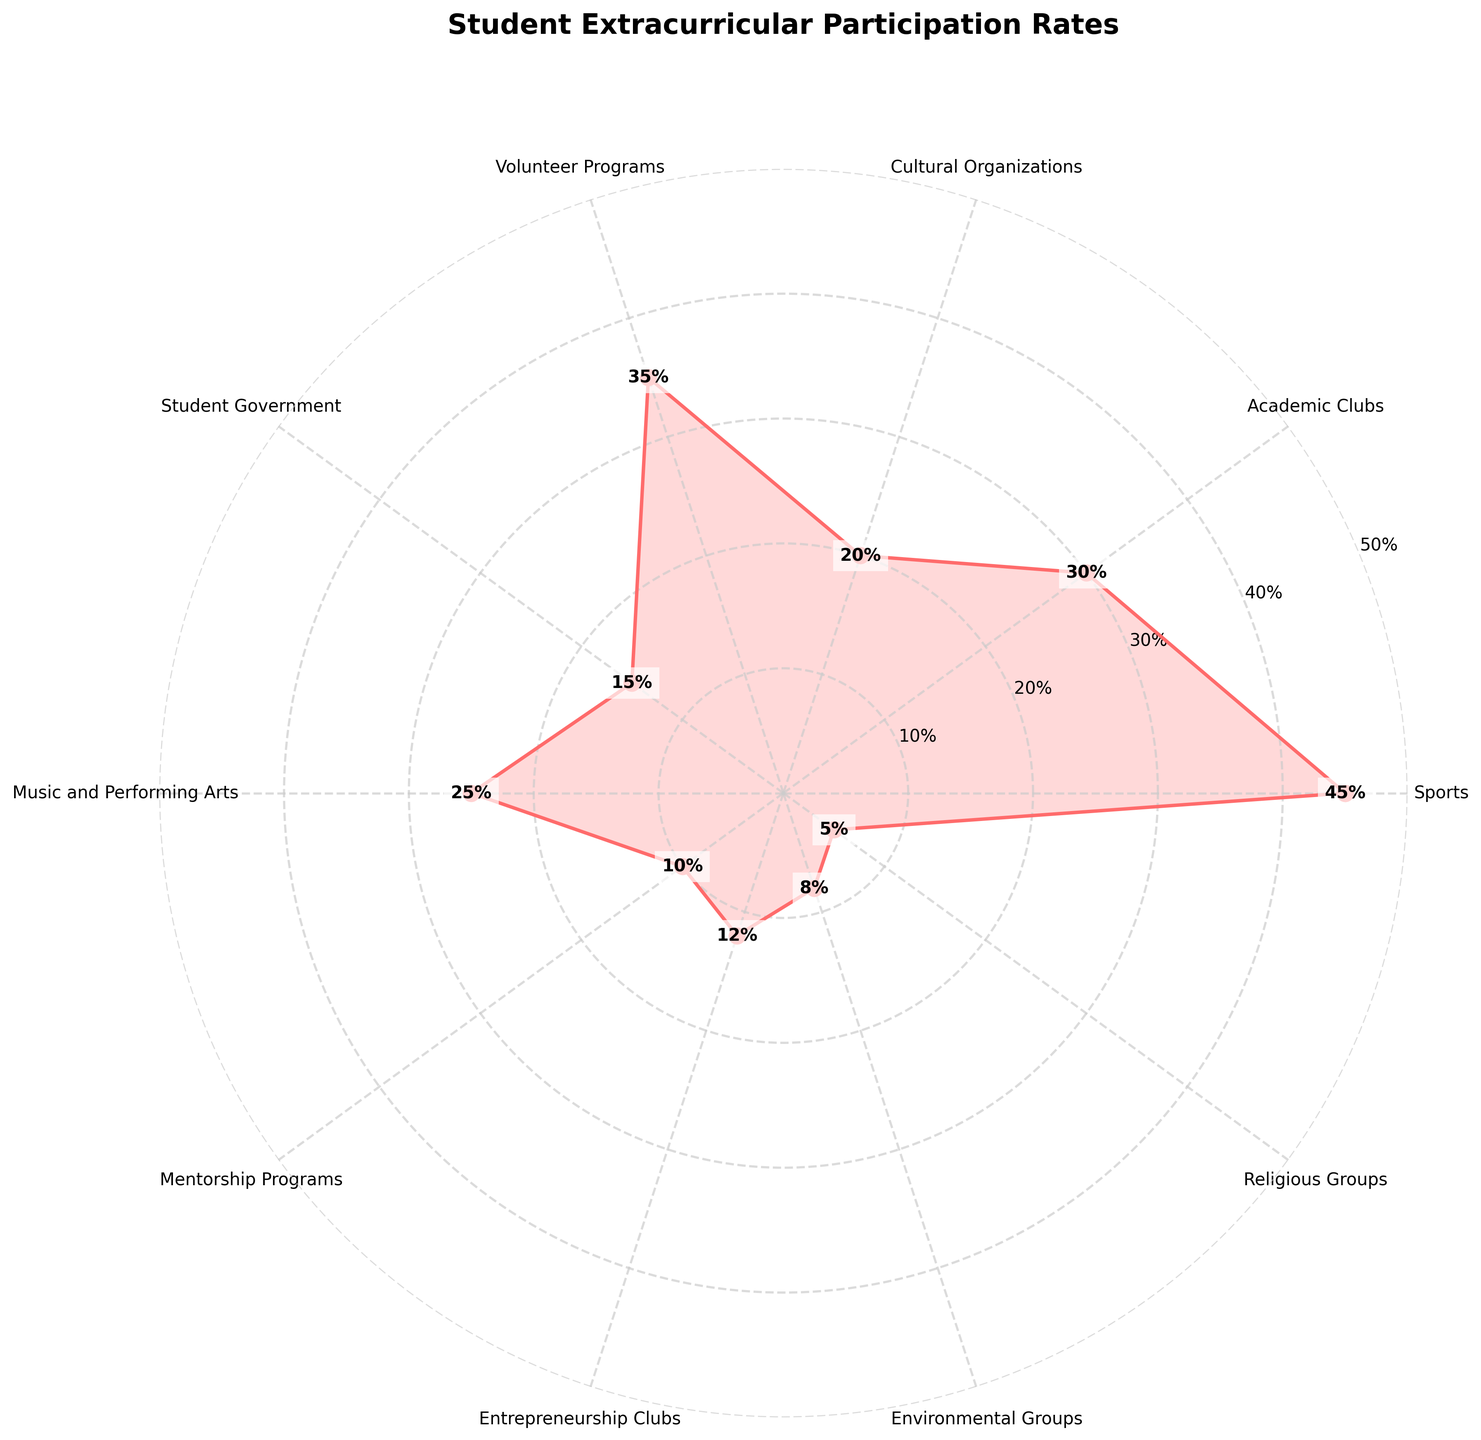What is the title of the figure? The title of the figure is usually located at the top and describes the main subject of the plot. In this case, the title is clear and bold at the top.
Answer: "Student Extracurricular Participation Rates" What activity has the highest participation rate? Look at the labels and their corresponding values on the figure. The activity that reaches the furthest from the center has the highest rate.
Answer: Sports What is the difference in participation rate between Sports and Religious Groups? Identify the rates for Sports (45%) and Religious Groups (5%). Subtract the smaller rate from the larger one.
Answer: 40% Which activity has the closest participation rate to Academic Clubs? Identify the rate for Academic Clubs (30%) and compare it to the rates of other activities. Volunteer Programs (35%) and Music and Performing Arts (25%) are close.
Answer: Music and Performing Arts What are the activities with a participation rate of at least 25%? Look for activities whose petals extend to 25% or more in the rose chart. These include Sports, Academic Clubs, Volunteer Programs, and Music and Performing Arts.
Answer: Sports, Academic Clubs, Volunteer Programs, Music and Performing Arts What is the median participation rate of all activities? First, list all the participation rates (45, 30, 20, 35, 15, 25, 10, 12, 8, 5). Arrange them in ascending order (5, 8, 10, 12, 15, 20, 25, 30, 35, 45). Since there are 10 data points (even number), take the average of the 5th and 6th values.
Answer: 17.5% Which two activities combined have a participation rate similar to Volunteer Programs? The participation rate of Volunteer Programs is 35%. Look for two activities whose rates sum up to 35%. Academic Clubs (30%) + Religious Groups (5%) = 35%.
Answer: Academic Clubs and Religious Groups Are there more activities with participation rates greater than 20% or less than 20%? Count the number of activities above and below 20%. Above: Sports, Academic Clubs, Volunteer Programs, Music and Performing Arts (4). Below: Cultural Organizations, Student Government, Mentorship Programs, Entrepreneurship Clubs, Environmental Groups, Religious Groups (6).
Answer: Less than 20% What percentage of the activities have a participation rate of at least 15%? Identify the activities that have a rate of 15% or more. There are Sports, Academic Clubs, Cultural Organizations, Volunteer Programs, Music and Performing Arts, and Student Government (6 activities out of 10). Divide the number of qualifying activities by the total number of activities and multiply by 100.
Answer: 60% 